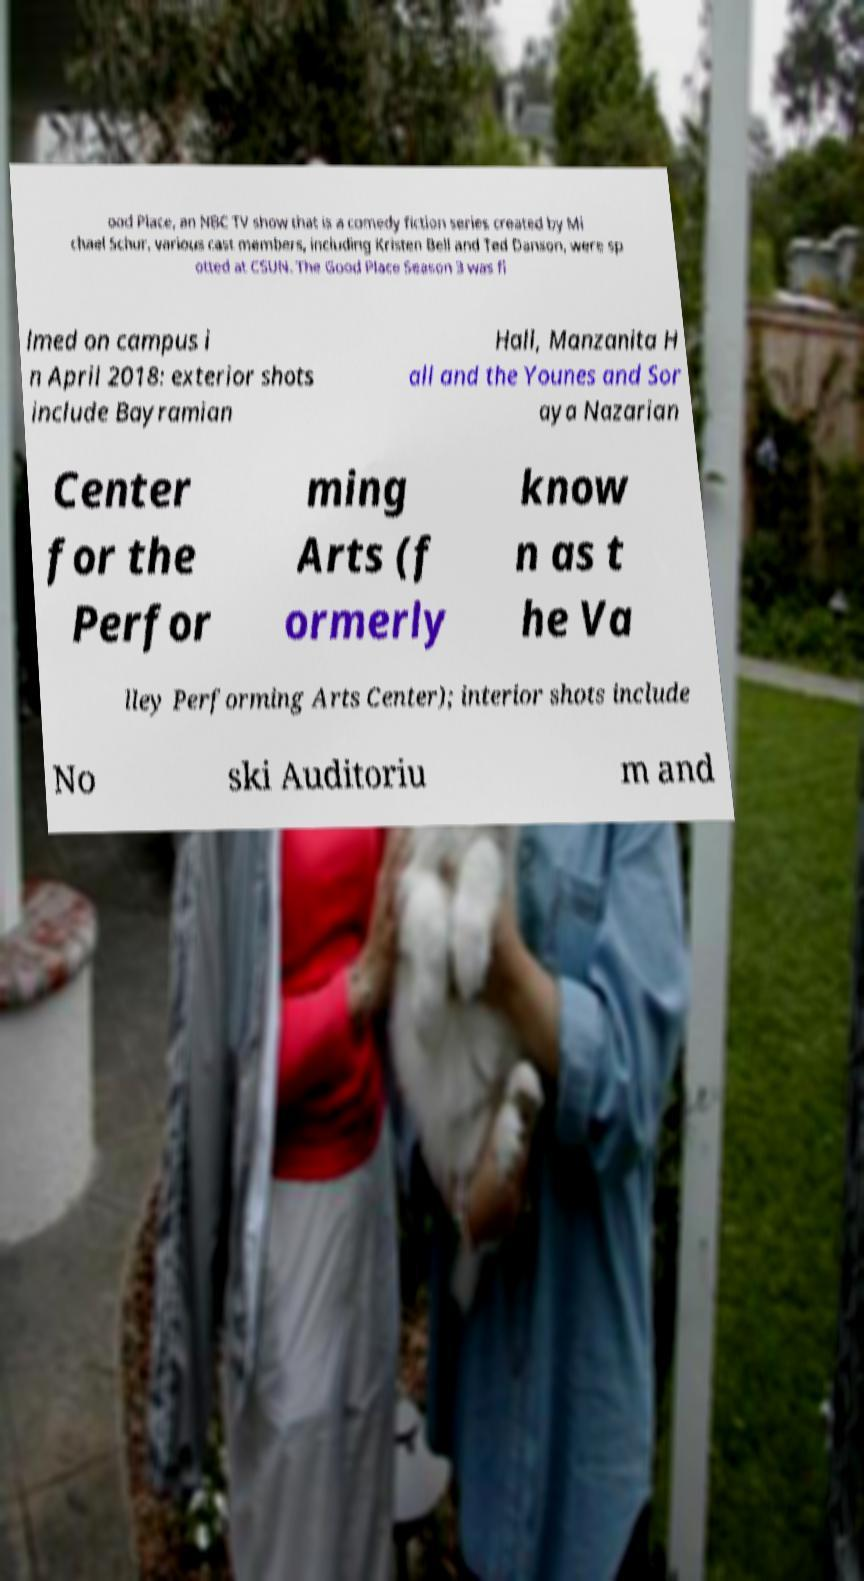Can you read and provide the text displayed in the image?This photo seems to have some interesting text. Can you extract and type it out for me? ood Place, an NBC TV show that is a comedy fiction series created by Mi chael Schur, various cast members, including Kristen Bell and Ted Danson, were sp otted at CSUN. The Good Place Season 3 was fi lmed on campus i n April 2018: exterior shots include Bayramian Hall, Manzanita H all and the Younes and Sor aya Nazarian Center for the Perfor ming Arts (f ormerly know n as t he Va lley Performing Arts Center); interior shots include No ski Auditoriu m and 